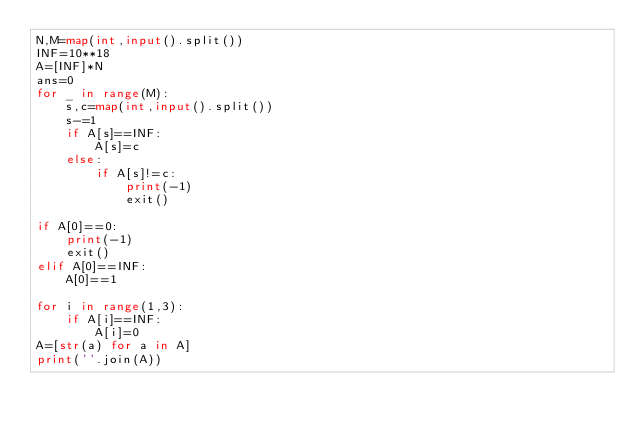<code> <loc_0><loc_0><loc_500><loc_500><_Python_>N,M=map(int,input().split())
INF=10**18
A=[INF]*N
ans=0
for _ in range(M):
    s,c=map(int,input().split())
    s-=1
    if A[s]==INF:
        A[s]=c
    else:
        if A[s]!=c:
            print(-1)
            exit()

if A[0]==0:
    print(-1)
    exit()
elif A[0]==INF:
    A[0]==1

for i in range(1,3):
    if A[i]==INF:
        A[i]=0
A=[str(a) for a in A]
print(''.join(A))</code> 